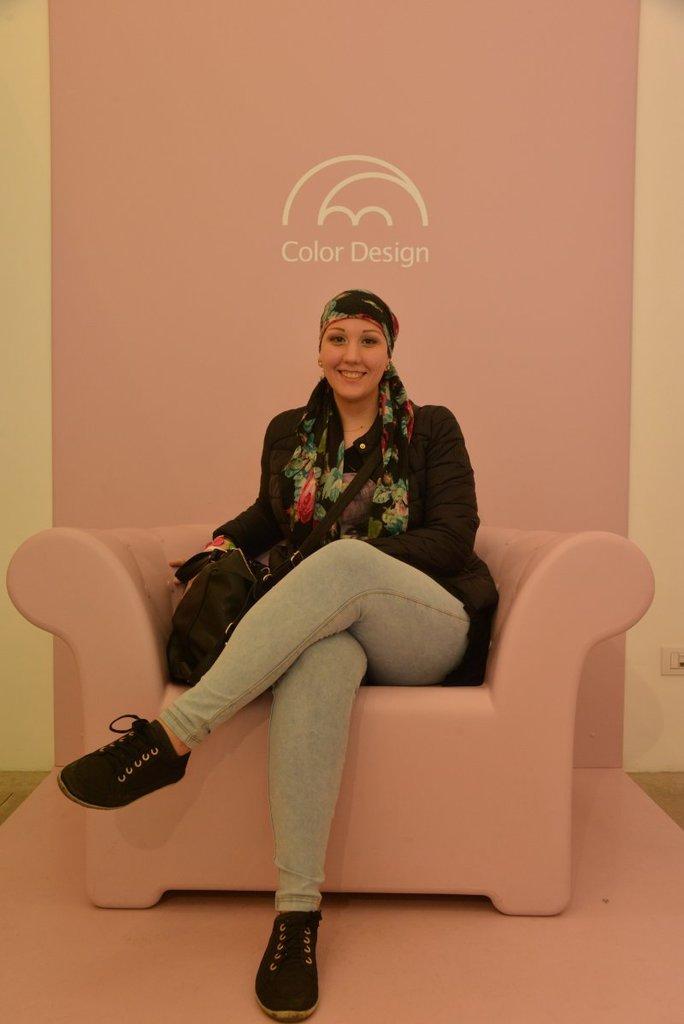In one or two sentences, can you explain what this image depicts? In this see image I can see a woman is sitting on a sofa. I can see a smile on her face and she is wearing a scarf. Here I can see a bag. 